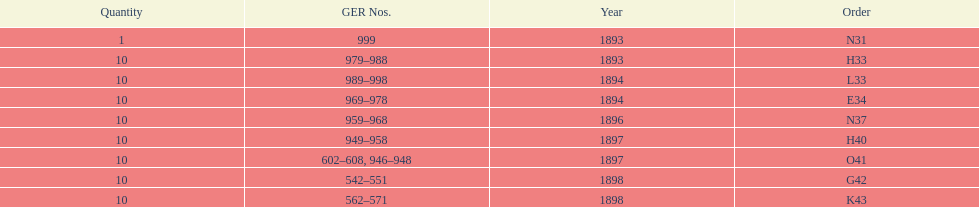What is the amount of years with a volume of 10? 5. 